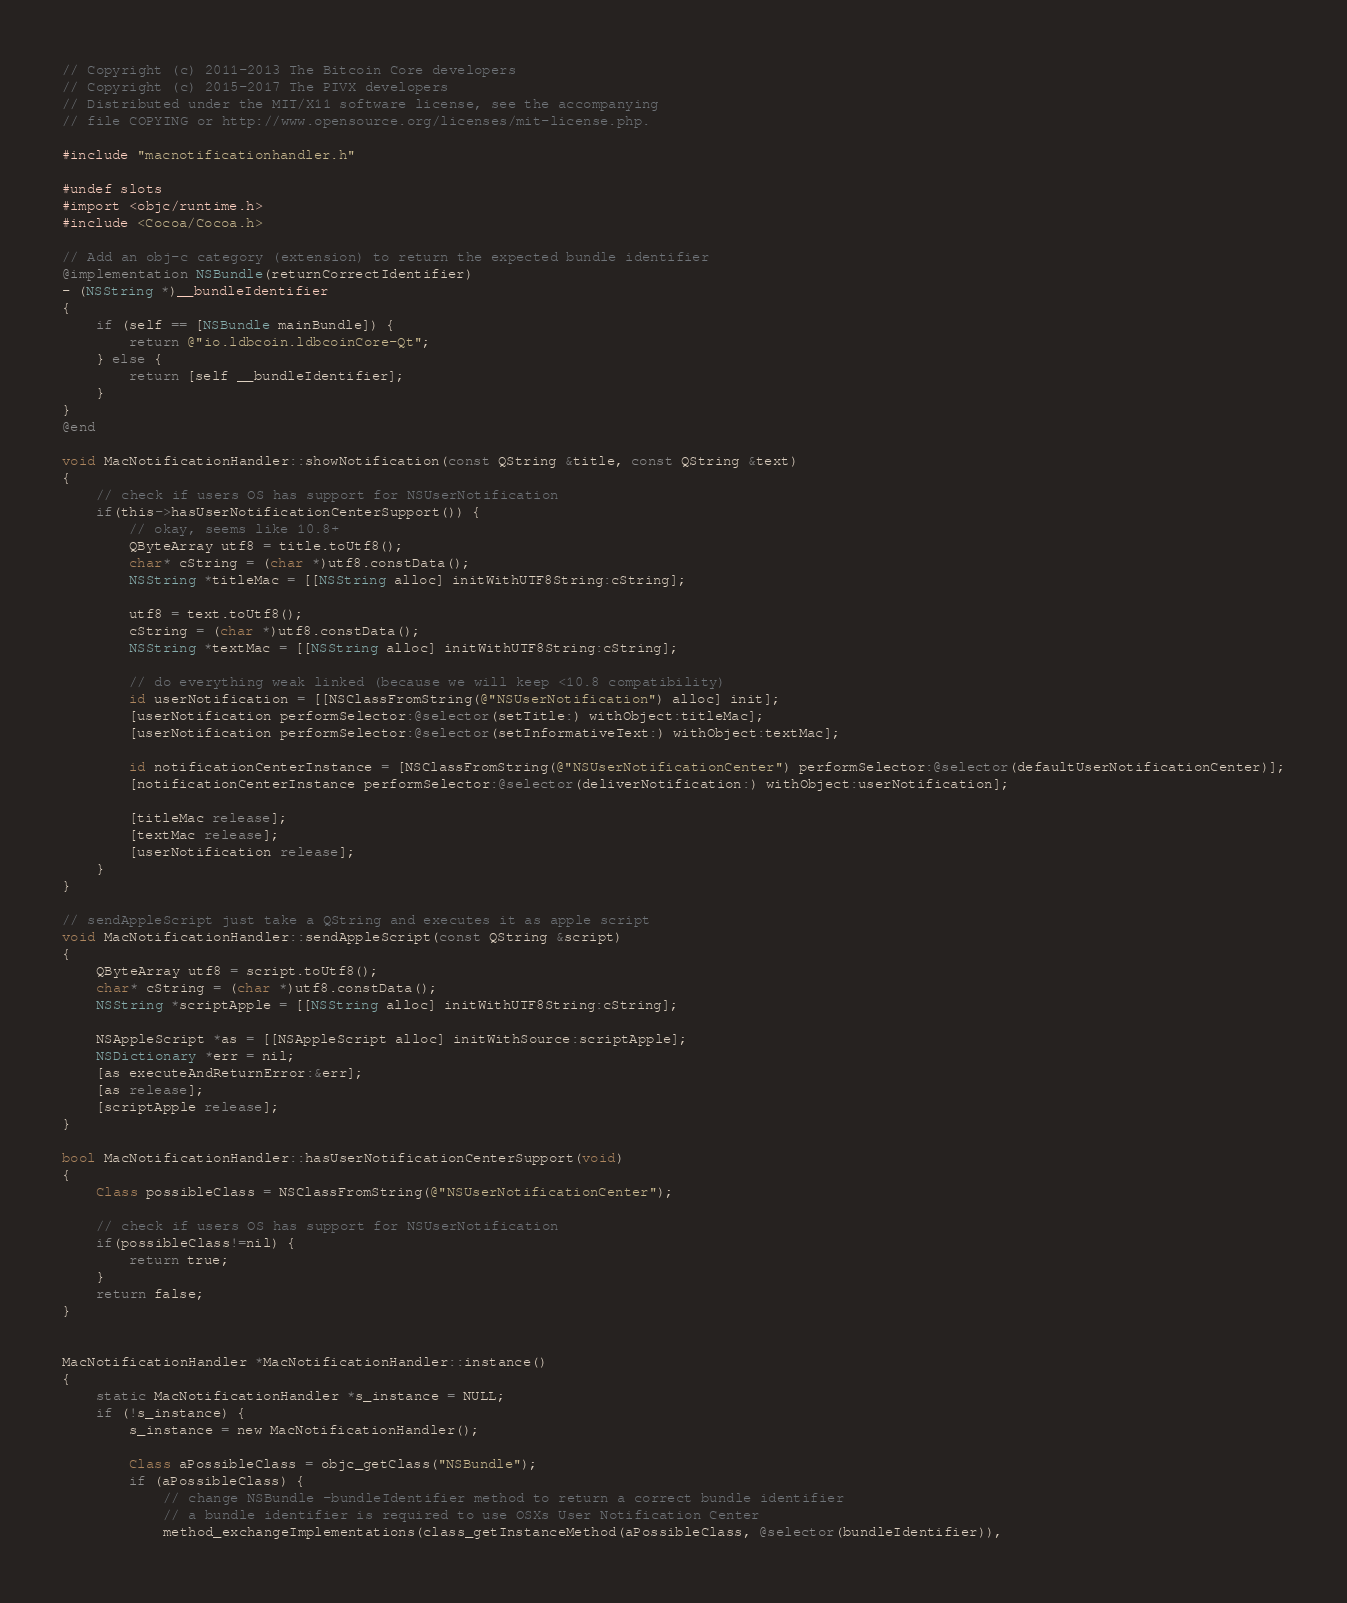<code> <loc_0><loc_0><loc_500><loc_500><_ObjectiveC_>// Copyright (c) 2011-2013 The Bitcoin Core developers
// Copyright (c) 2015-2017 The PIVX developers
// Distributed under the MIT/X11 software license, see the accompanying
// file COPYING or http://www.opensource.org/licenses/mit-license.php.

#include "macnotificationhandler.h"

#undef slots
#import <objc/runtime.h>
#include <Cocoa/Cocoa.h>

// Add an obj-c category (extension) to return the expected bundle identifier
@implementation NSBundle(returnCorrectIdentifier)
- (NSString *)__bundleIdentifier
{
    if (self == [NSBundle mainBundle]) {
        return @"io.ldbcoin.ldbcoinCore-Qt";
    } else {
        return [self __bundleIdentifier];
    }
}
@end

void MacNotificationHandler::showNotification(const QString &title, const QString &text)
{
    // check if users OS has support for NSUserNotification
    if(this->hasUserNotificationCenterSupport()) {
        // okay, seems like 10.8+
        QByteArray utf8 = title.toUtf8();
        char* cString = (char *)utf8.constData();
        NSString *titleMac = [[NSString alloc] initWithUTF8String:cString];

        utf8 = text.toUtf8();
        cString = (char *)utf8.constData();
        NSString *textMac = [[NSString alloc] initWithUTF8String:cString];

        // do everything weak linked (because we will keep <10.8 compatibility)
        id userNotification = [[NSClassFromString(@"NSUserNotification") alloc] init];
        [userNotification performSelector:@selector(setTitle:) withObject:titleMac];
        [userNotification performSelector:@selector(setInformativeText:) withObject:textMac];

        id notificationCenterInstance = [NSClassFromString(@"NSUserNotificationCenter") performSelector:@selector(defaultUserNotificationCenter)];
        [notificationCenterInstance performSelector:@selector(deliverNotification:) withObject:userNotification];

        [titleMac release];
        [textMac release];
        [userNotification release];
    }
}

// sendAppleScript just take a QString and executes it as apple script
void MacNotificationHandler::sendAppleScript(const QString &script)
{
    QByteArray utf8 = script.toUtf8();
    char* cString = (char *)utf8.constData();
    NSString *scriptApple = [[NSString alloc] initWithUTF8String:cString];

    NSAppleScript *as = [[NSAppleScript alloc] initWithSource:scriptApple];
    NSDictionary *err = nil;
    [as executeAndReturnError:&err];
    [as release];
    [scriptApple release];
}

bool MacNotificationHandler::hasUserNotificationCenterSupport(void)
{
    Class possibleClass = NSClassFromString(@"NSUserNotificationCenter");

    // check if users OS has support for NSUserNotification
    if(possibleClass!=nil) {
        return true;
    }
    return false;
}


MacNotificationHandler *MacNotificationHandler::instance()
{
    static MacNotificationHandler *s_instance = NULL;
    if (!s_instance) {
        s_instance = new MacNotificationHandler();

        Class aPossibleClass = objc_getClass("NSBundle");
        if (aPossibleClass) {
            // change NSBundle -bundleIdentifier method to return a correct bundle identifier
            // a bundle identifier is required to use OSXs User Notification Center
            method_exchangeImplementations(class_getInstanceMethod(aPossibleClass, @selector(bundleIdentifier)),</code> 